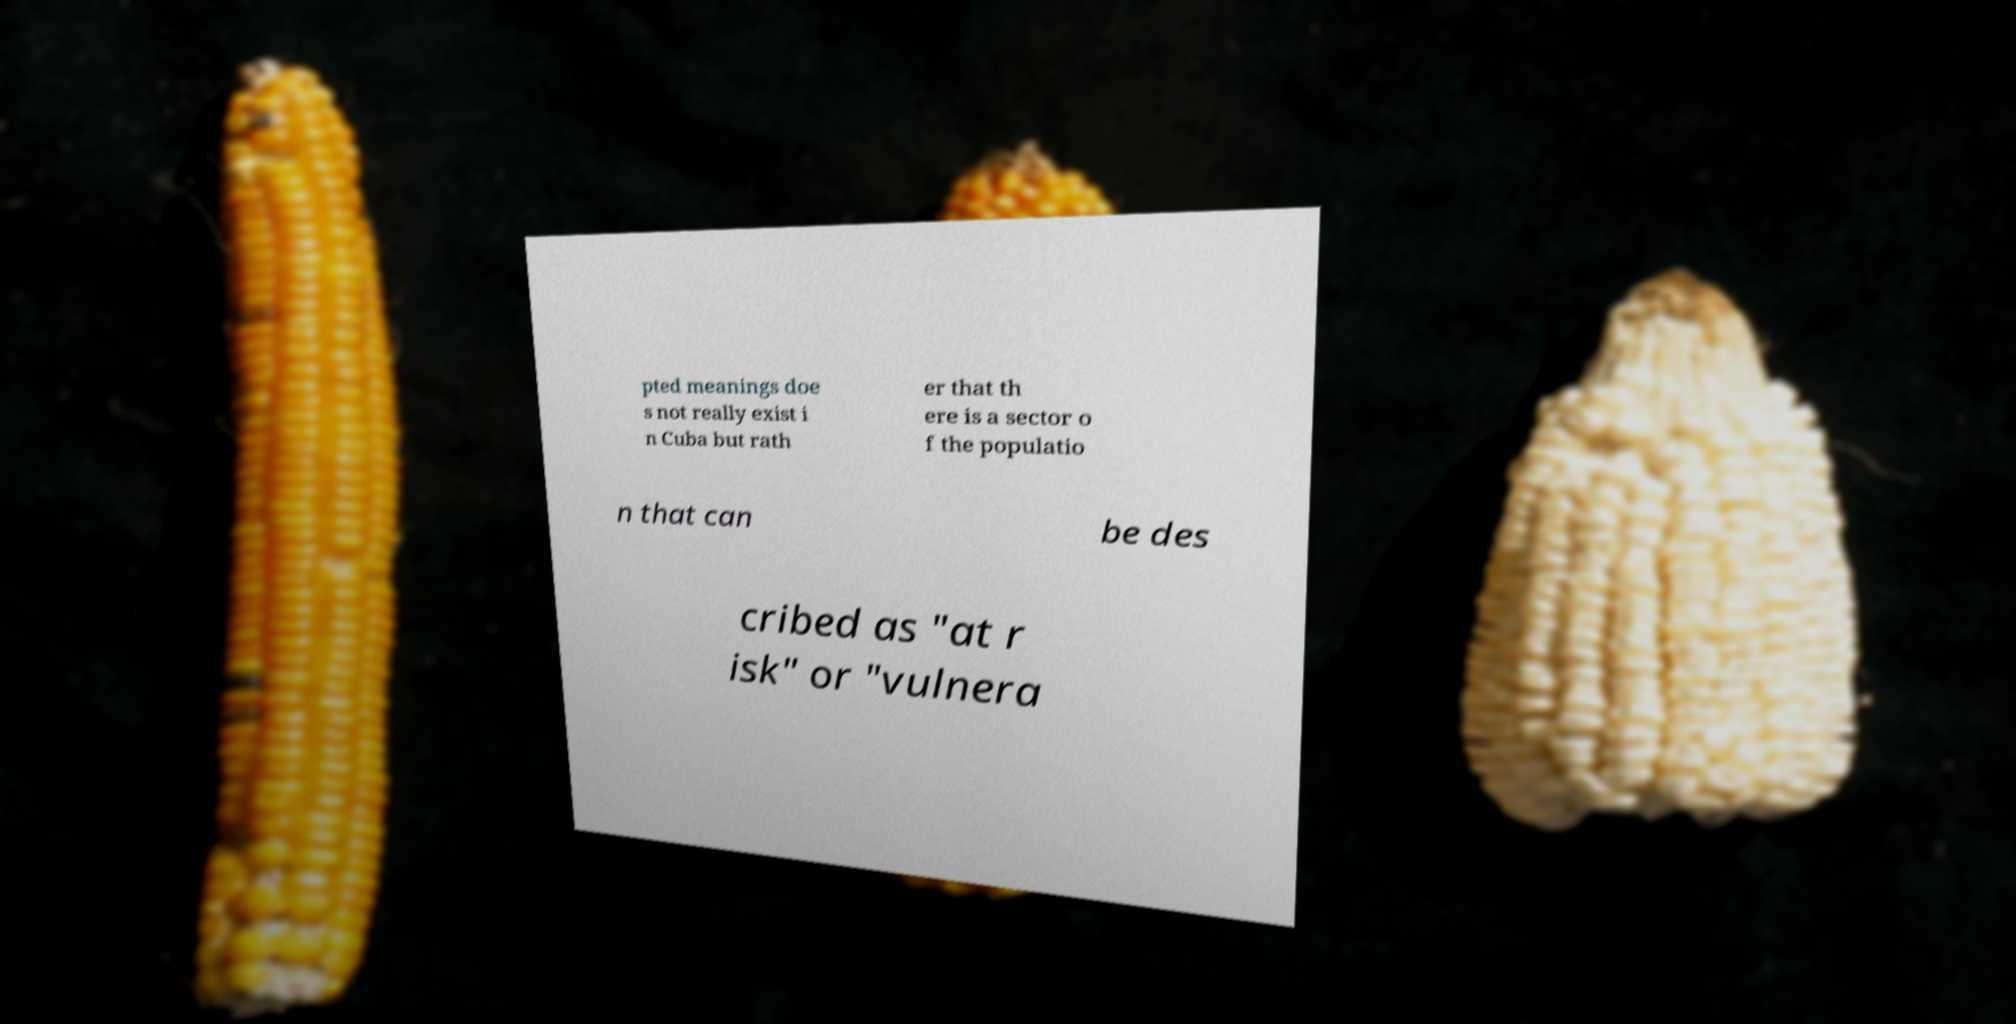Please read and relay the text visible in this image. What does it say? pted meanings doe s not really exist i n Cuba but rath er that th ere is a sector o f the populatio n that can be des cribed as "at r isk" or "vulnera 